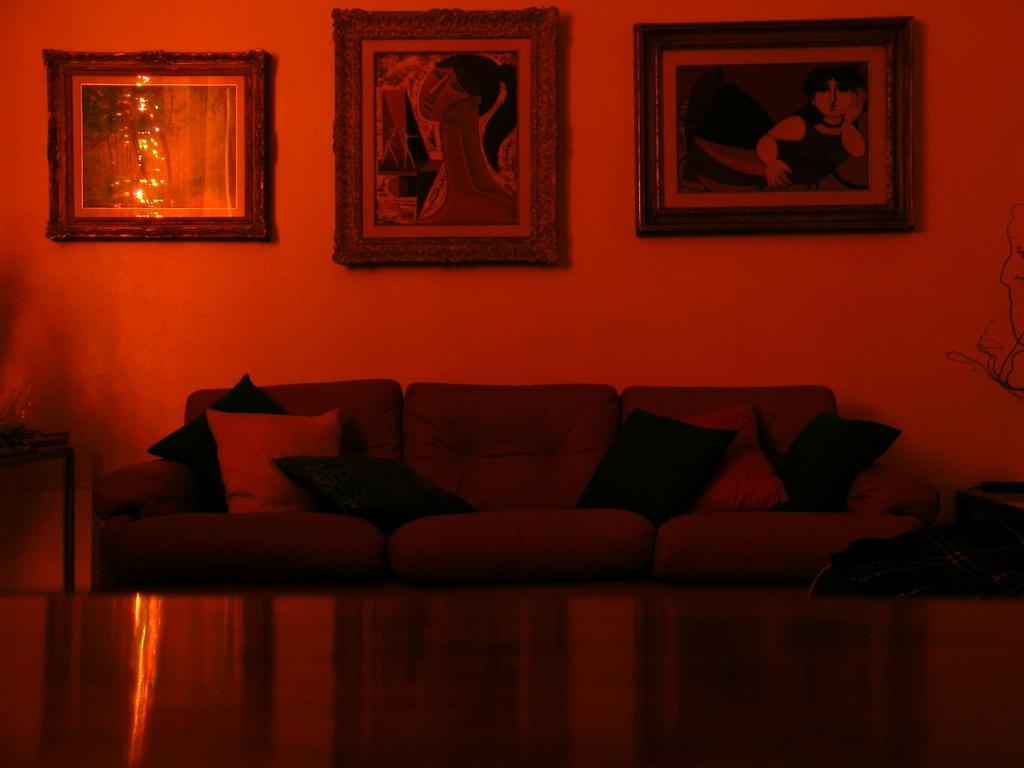In one or two sentences, can you explain what this image depicts? In this picture there is a couch with some pillows and also there are some photo frames on the wall. 